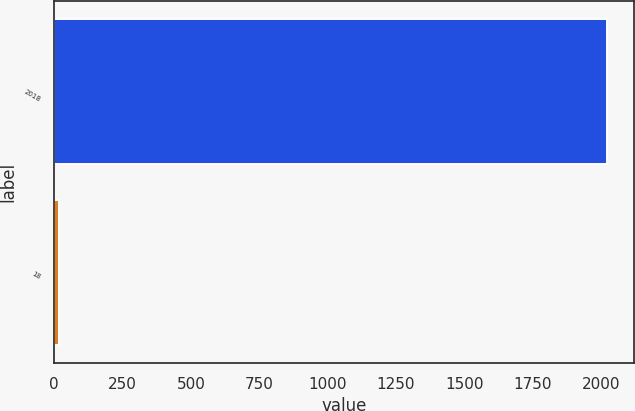Convert chart. <chart><loc_0><loc_0><loc_500><loc_500><bar_chart><fcel>2018<fcel>18<nl><fcel>2021<fcel>17<nl></chart> 